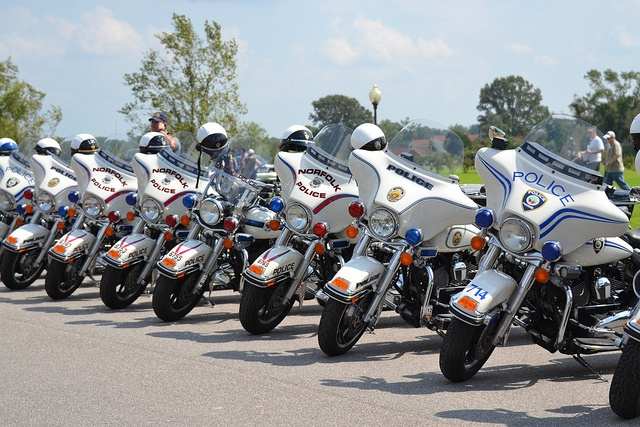Describe the objects in this image and their specific colors. I can see motorcycle in lightblue, black, gray, darkgray, and white tones, motorcycle in lightblue, black, darkgray, gray, and white tones, motorcycle in lightblue, black, darkgray, gray, and white tones, motorcycle in lightblue, black, gray, darkgray, and white tones, and motorcycle in lightblue, black, gray, darkgray, and white tones in this image. 